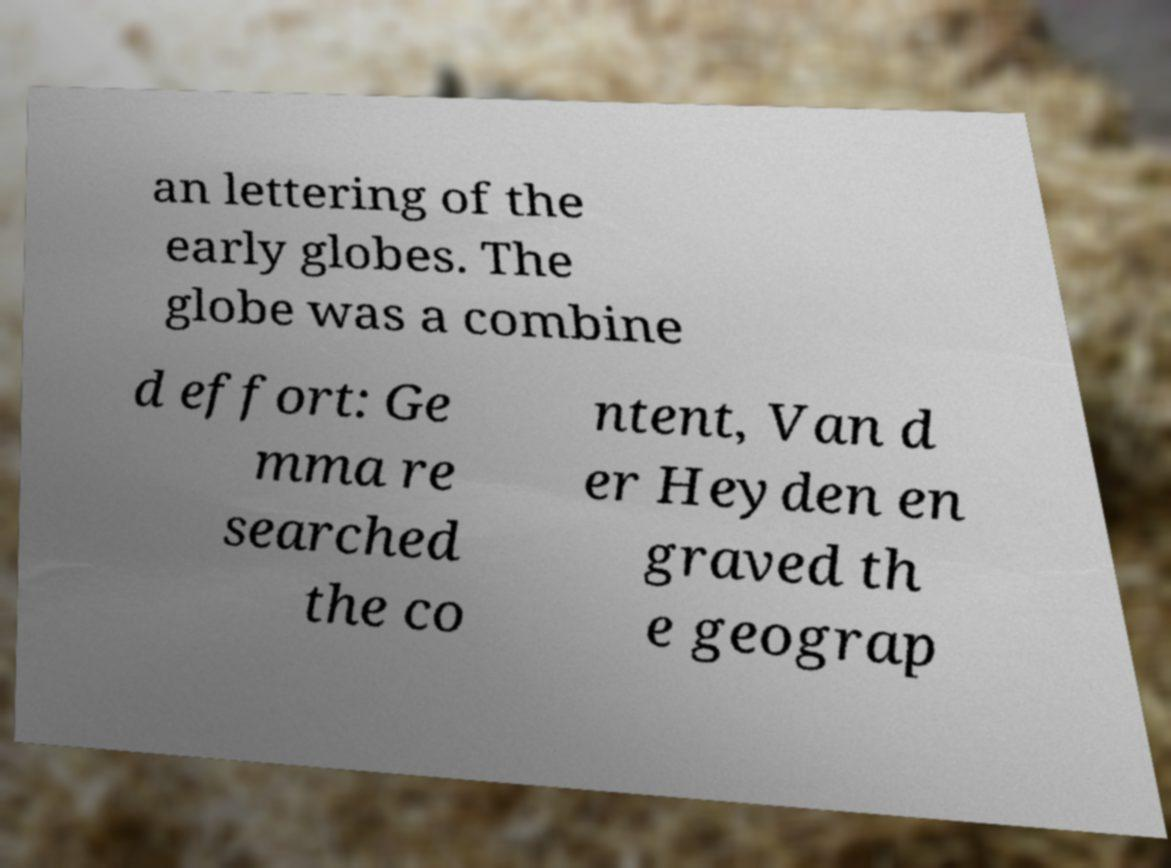What messages or text are displayed in this image? I need them in a readable, typed format. an lettering of the early globes. The globe was a combine d effort: Ge mma re searched the co ntent, Van d er Heyden en graved th e geograp 